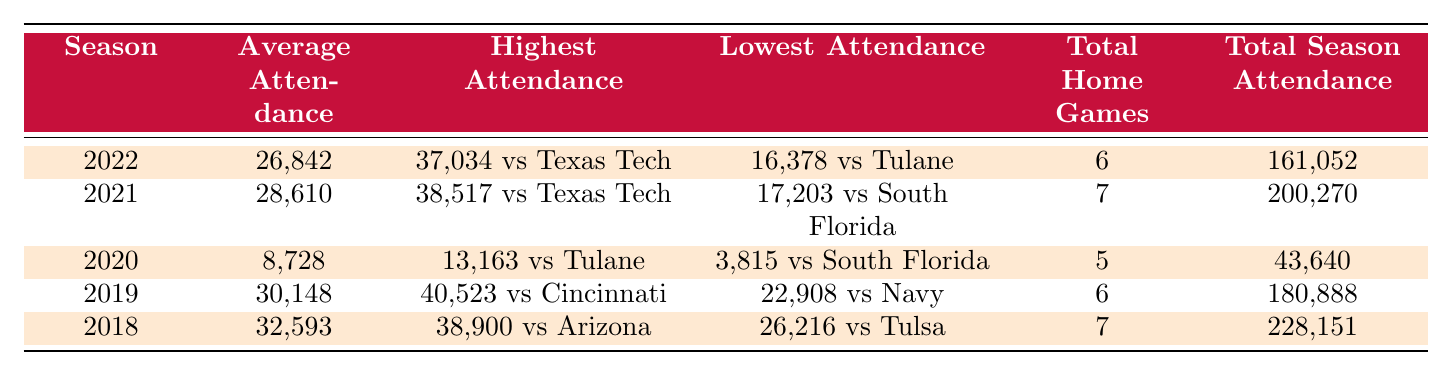What was the average attendance in the 2022 season? The table shows that the average attendance for the 2022 season was 26,842.
Answer: 26,842 Which season had the highest total season attendance? Looking at the total season attendance, the 2018 season had the highest figure at 228,151.
Answer: 2018 What is the difference between the highest and lowest attendance in the 2021 season? The highest attendance in 2021 was 38,517 and the lowest was 17,203. The difference is calculated as 38,517 - 17,203 = 21,314.
Answer: 21,314 In what year did the University of Houston have the lowest average attendance? The average attendance figures show that 2020 had the lowest average attendance at 8,728.
Answer: 2020 How many total home games were played in the last five seasons combined? By summing the total home games from each season: 6 + 7 + 5 + 6 + 7 = 31 total home games were played over the last five seasons.
Answer: 31 Was the highest attendance in 2019 greater than in 2022? The highest attendance in 2019 was 40,523 while in 2022 it was 37,034, making 40,523 greater than 37,034. Thus, the statement is true.
Answer: True What was the average attendance over the last five seasons? The average attendance is calculated by summing the average attendances: (26,842 + 28,610 + 8,728 + 30,148 + 32,593) / 5 = 25,984.2, which rounds to 25,984.
Answer: 25,984 Which season experienced a significant drop in average attendance compared to the previous year? Comparing seasons, 2020 shows a significant drop from 28,610 in 2019 to 8,728 in 2020, indicating the sharpest decline.
Answer: 2020 What was the total season attendance for the 2019 season? The table indicates that the total season attendance for the 2019 season was 180,888.
Answer: 180,888 Was the lowest attendance in 2018 greater than the highest attendance in 2020? The lowest attendance in 2018 was 26,216 while the highest in 2020 was 13,163. Since 26,216 is greater than 13,163, the statement is true.
Answer: True 